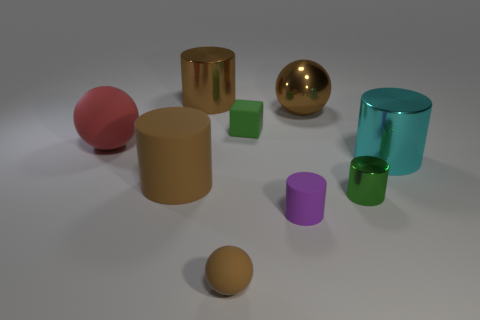Subtract all brown spheres. How many spheres are left? 1 Subtract all red cubes. How many brown balls are left? 2 Subtract all green cylinders. How many cylinders are left? 4 Subtract 3 cylinders. How many cylinders are left? 2 Subtract all blocks. How many objects are left? 8 Subtract 0 gray cylinders. How many objects are left? 9 Subtract all purple spheres. Subtract all yellow cubes. How many spheres are left? 3 Subtract all small shiny cylinders. Subtract all small purple shiny objects. How many objects are left? 8 Add 8 large red objects. How many large red objects are left? 9 Add 4 big metallic cylinders. How many big metallic cylinders exist? 6 